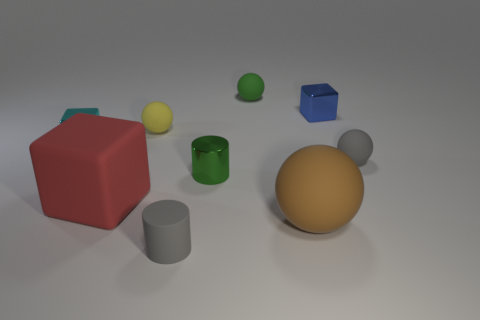Subtract all cylinders. How many objects are left? 7 Subtract 0 yellow cylinders. How many objects are left? 9 Subtract all tiny brown spheres. Subtract all red objects. How many objects are left? 8 Add 8 yellow objects. How many yellow objects are left? 9 Add 5 blue blocks. How many blue blocks exist? 6 